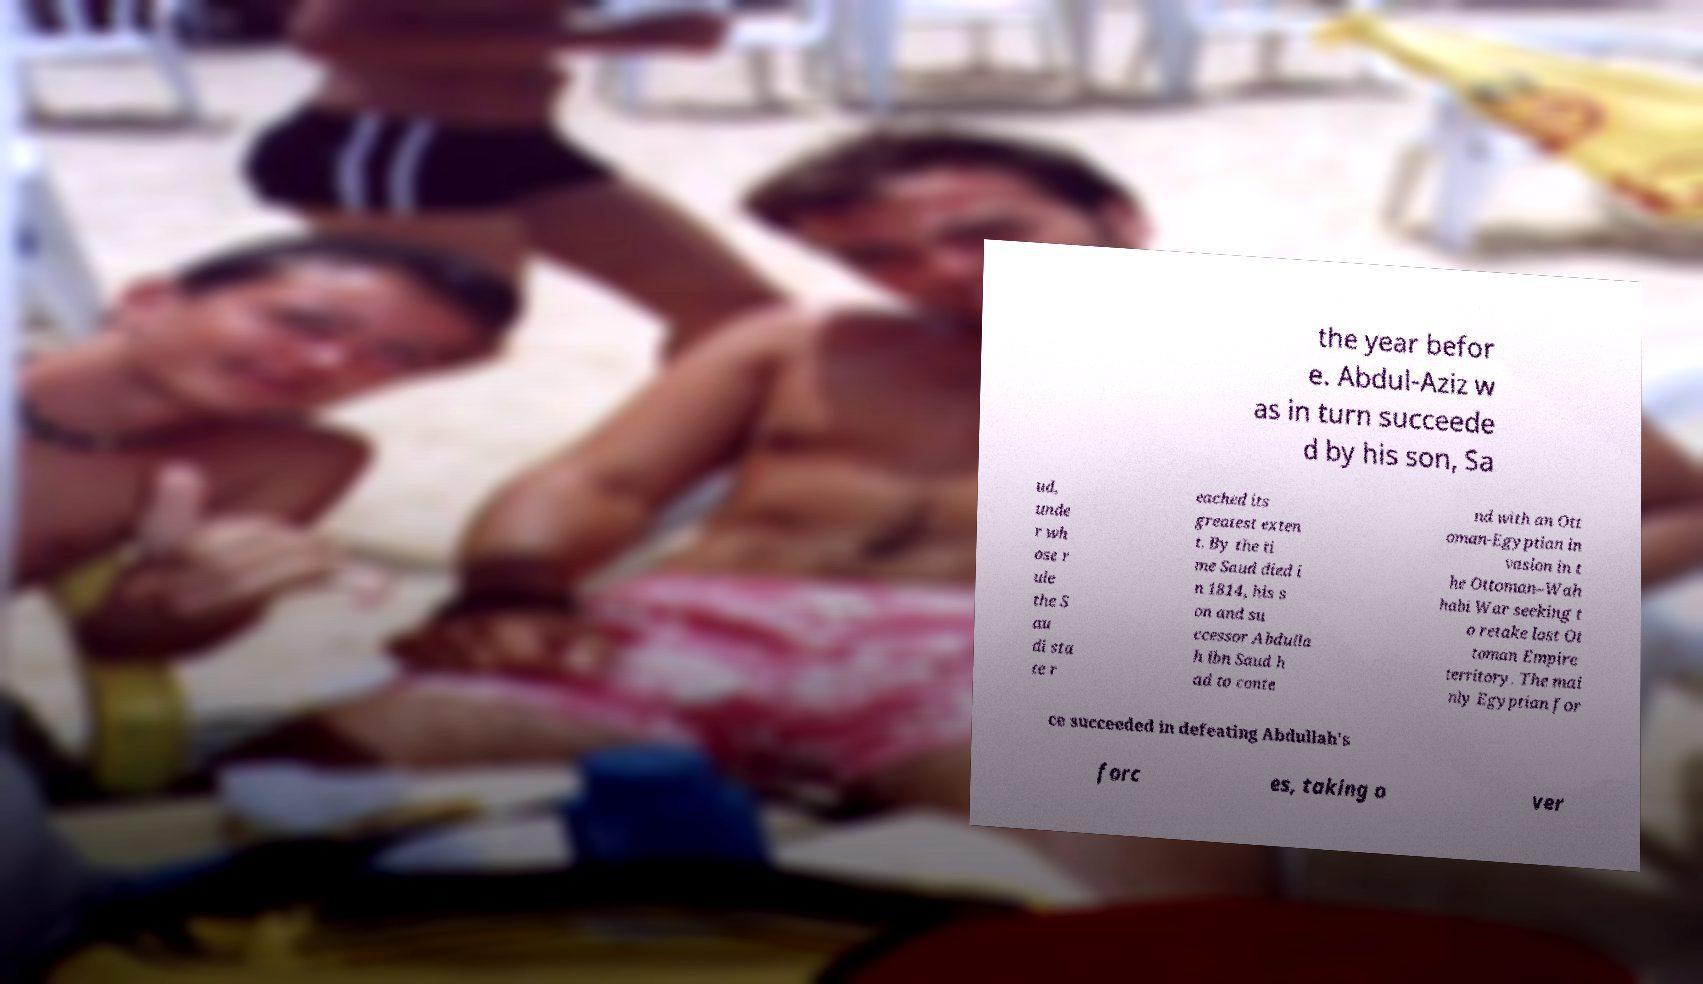I need the written content from this picture converted into text. Can you do that? the year befor e. Abdul-Aziz w as in turn succeede d by his son, Sa ud, unde r wh ose r ule the S au di sta te r eached its greatest exten t. By the ti me Saud died i n 1814, his s on and su ccessor Abdulla h ibn Saud h ad to conte nd with an Ott oman-Egyptian in vasion in t he Ottoman–Wah habi War seeking t o retake lost Ot toman Empire territory. The mai nly Egyptian for ce succeeded in defeating Abdullah's forc es, taking o ver 